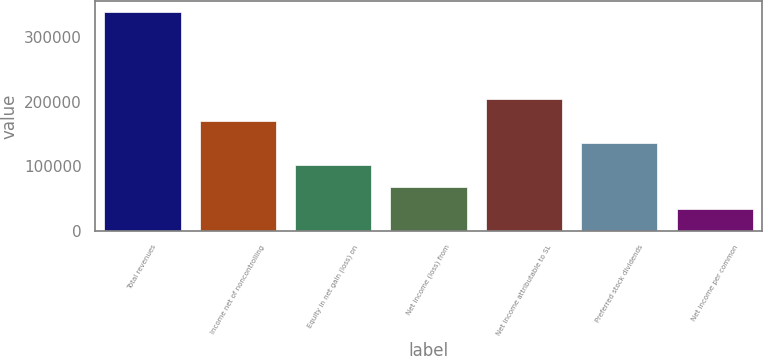<chart> <loc_0><loc_0><loc_500><loc_500><bar_chart><fcel>Total revenues<fcel>Income net of noncontrolling<fcel>Equity in net gain (loss) on<fcel>Net income (loss) from<fcel>Net income attributable to SL<fcel>Preferred stock dividends<fcel>Net income per common<nl><fcel>339133<fcel>169567<fcel>101740<fcel>67826.8<fcel>203480<fcel>135653<fcel>33913.6<nl></chart> 